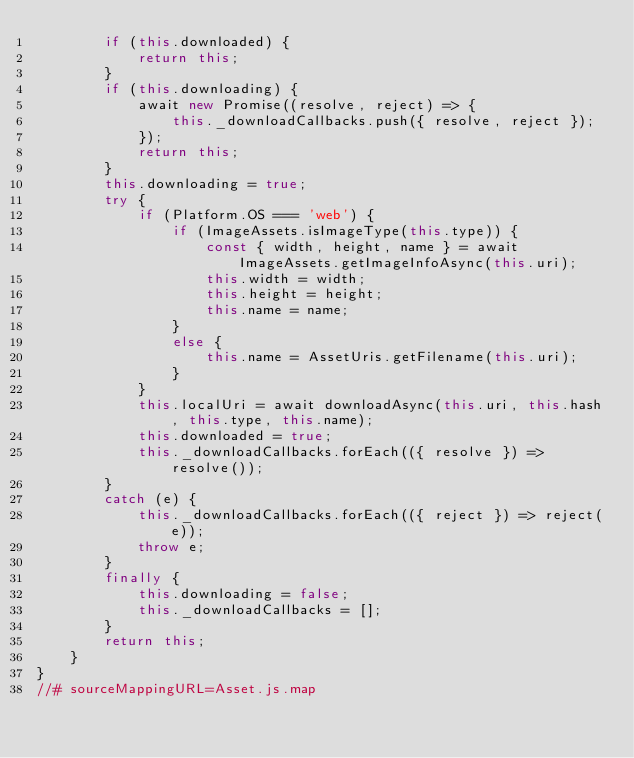Convert code to text. <code><loc_0><loc_0><loc_500><loc_500><_JavaScript_>        if (this.downloaded) {
            return this;
        }
        if (this.downloading) {
            await new Promise((resolve, reject) => {
                this._downloadCallbacks.push({ resolve, reject });
            });
            return this;
        }
        this.downloading = true;
        try {
            if (Platform.OS === 'web') {
                if (ImageAssets.isImageType(this.type)) {
                    const { width, height, name } = await ImageAssets.getImageInfoAsync(this.uri);
                    this.width = width;
                    this.height = height;
                    this.name = name;
                }
                else {
                    this.name = AssetUris.getFilename(this.uri);
                }
            }
            this.localUri = await downloadAsync(this.uri, this.hash, this.type, this.name);
            this.downloaded = true;
            this._downloadCallbacks.forEach(({ resolve }) => resolve());
        }
        catch (e) {
            this._downloadCallbacks.forEach(({ reject }) => reject(e));
            throw e;
        }
        finally {
            this.downloading = false;
            this._downloadCallbacks = [];
        }
        return this;
    }
}
//# sourceMappingURL=Asset.js.map</code> 